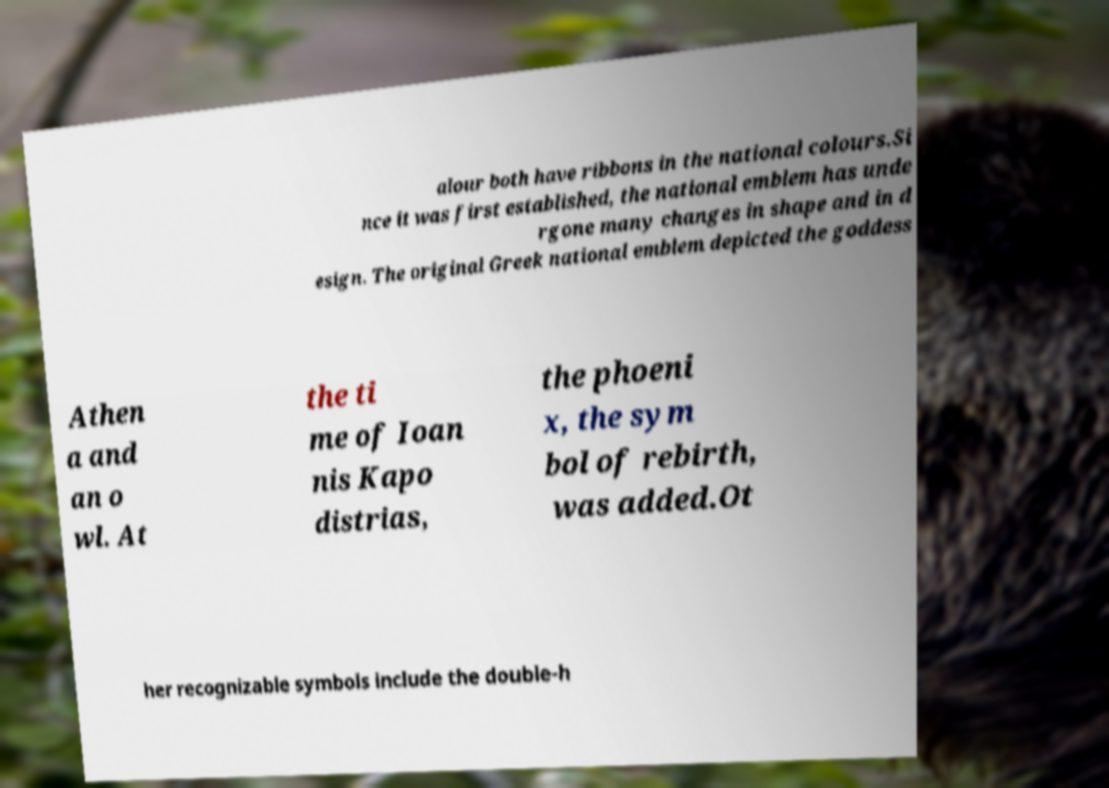Could you extract and type out the text from this image? alour both have ribbons in the national colours.Si nce it was first established, the national emblem has unde rgone many changes in shape and in d esign. The original Greek national emblem depicted the goddess Athen a and an o wl. At the ti me of Ioan nis Kapo distrias, the phoeni x, the sym bol of rebirth, was added.Ot her recognizable symbols include the double-h 